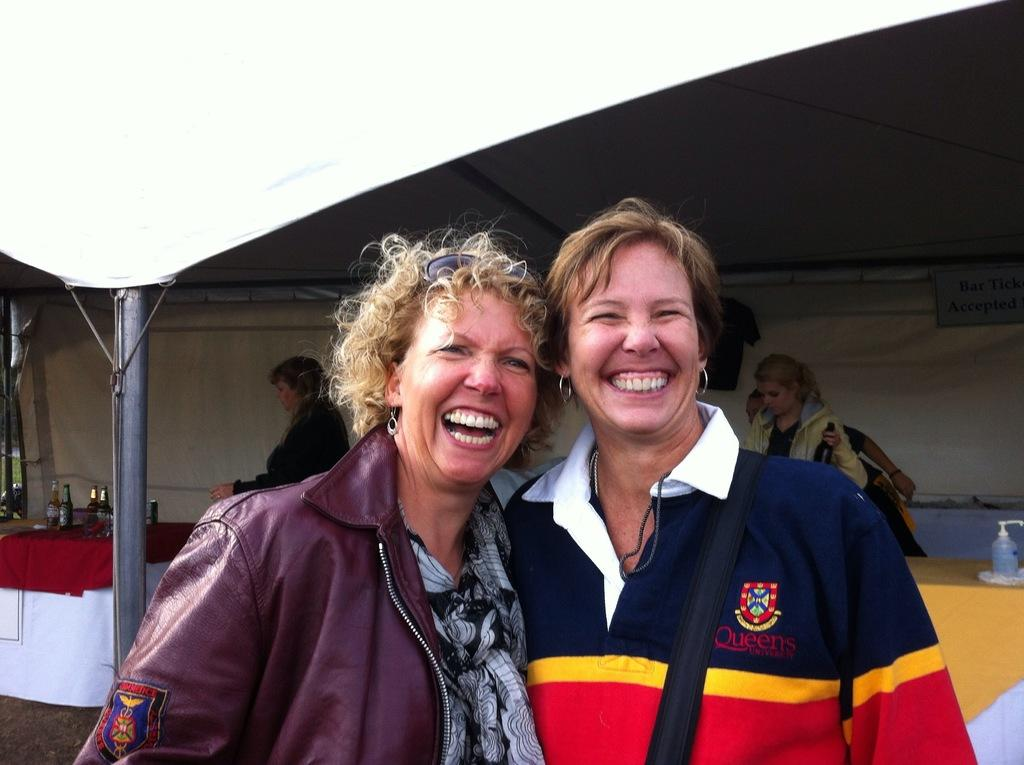Who or what can be seen in the image? There are people in the image. What objects are on the tables in the image? There are bottles on tables in the image. What type of shelter is present in the image? There is a tent in the image. What type of quartz can be seen in the image? There is no quartz present in the image. What kind of music is being played in the image? There is no information about music in the image. 